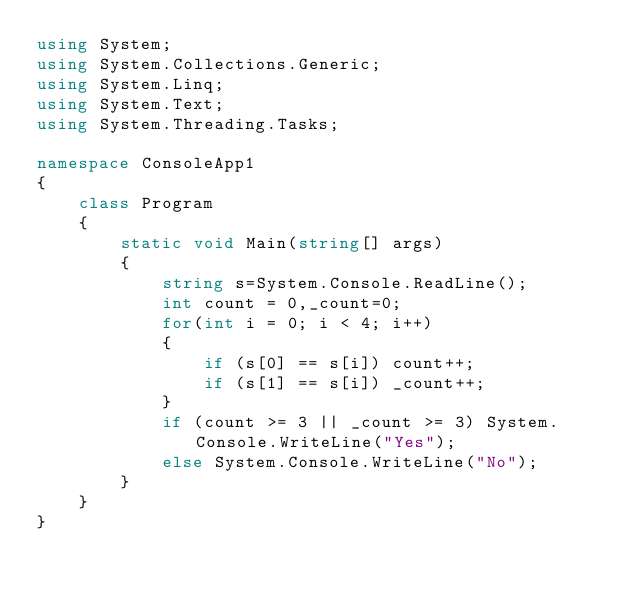<code> <loc_0><loc_0><loc_500><loc_500><_C#_>using System;
using System.Collections.Generic;
using System.Linq;
using System.Text;
using System.Threading.Tasks;

namespace ConsoleApp1
{
    class Program
    {
        static void Main(string[] args)
        {
            string s=System.Console.ReadLine();
            int count = 0,_count=0;
            for(int i = 0; i < 4; i++)
            {
                if (s[0] == s[i]) count++;
                if (s[1] == s[i]) _count++;
            }
            if (count >= 3 || _count >= 3) System.Console.WriteLine("Yes");
            else System.Console.WriteLine("No");
        }
    }
}</code> 